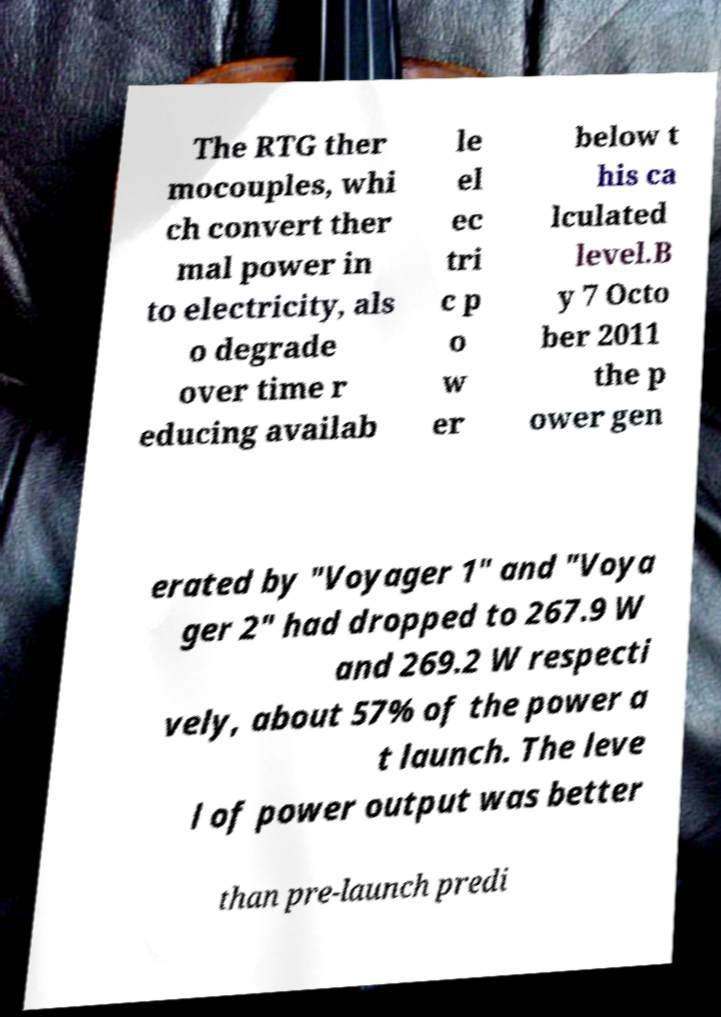Could you assist in decoding the text presented in this image and type it out clearly? The RTG ther mocouples, whi ch convert ther mal power in to electricity, als o degrade over time r educing availab le el ec tri c p o w er below t his ca lculated level.B y 7 Octo ber 2011 the p ower gen erated by "Voyager 1" and "Voya ger 2" had dropped to 267.9 W and 269.2 W respecti vely, about 57% of the power a t launch. The leve l of power output was better than pre-launch predi 